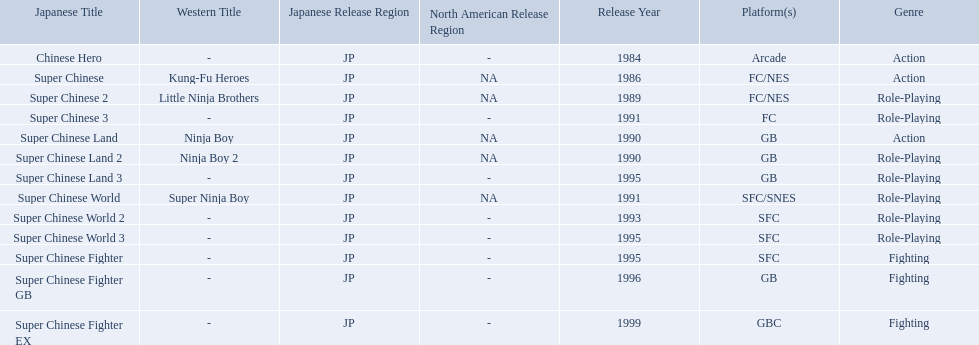Give me the full table as a dictionary. {'header': ['Japanese Title', 'Western Title', 'Japanese Release Region', 'North American Release Region', 'Release Year', 'Platform(s)', 'Genre'], 'rows': [['Chinese Hero', '-', 'JP', '-', '1984', 'Arcade', 'Action'], ['Super Chinese', 'Kung-Fu Heroes', 'JP', 'NA', '1986', 'FC/NES', 'Action'], ['Super Chinese 2', 'Little Ninja Brothers', 'JP', 'NA', '1989', 'FC/NES', 'Role-Playing'], ['Super Chinese 3', '-', 'JP', '-', '1991', 'FC', 'Role-Playing'], ['Super Chinese Land', 'Ninja Boy', 'JP', 'NA', '1990', 'GB', 'Action'], ['Super Chinese Land 2', 'Ninja Boy 2', 'JP', 'NA', '1990', 'GB', 'Role-Playing'], ['Super Chinese Land 3', '-', 'JP', '-', '1995', 'GB', 'Role-Playing'], ['Super Chinese World', 'Super Ninja Boy', 'JP', 'NA', '1991', 'SFC/SNES', 'Role-Playing'], ['Super Chinese World 2', '-', 'JP', '-', '1993', 'SFC', 'Role-Playing'], ['Super Chinese World 3', '-', 'JP', '-', '1995', 'SFC', 'Role-Playing'], ['Super Chinese Fighter', '-', 'JP', '-', '1995', 'SFC', 'Fighting'], ['Super Chinese Fighter GB', '-', 'JP', '-', '1996', 'GB', 'Fighting'], ['Super Chinese Fighter EX', '-', 'JP', '-', '1999', 'GBC', 'Fighting']]} Super ninja world was released in what countries? JP, NA. What was the original name for this title? Super Chinese World. 